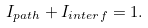Convert formula to latex. <formula><loc_0><loc_0><loc_500><loc_500>I _ { p a t h } + I _ { i n t e r f } = 1 .</formula> 